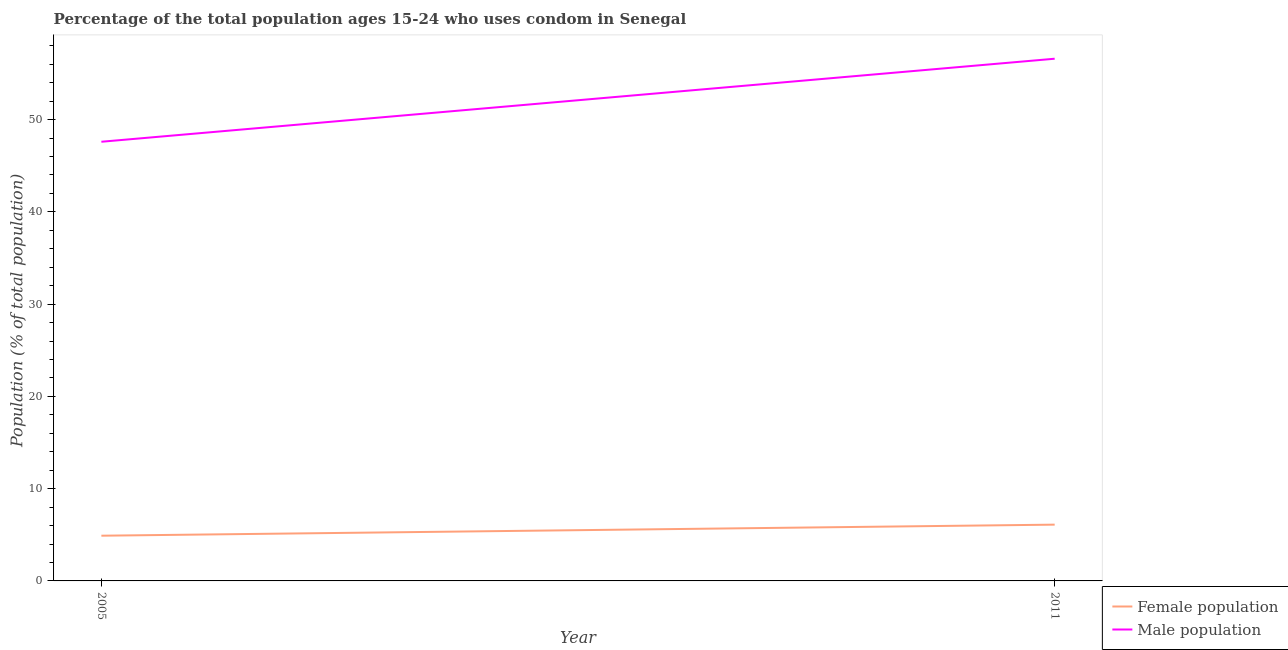Does the line corresponding to male population intersect with the line corresponding to female population?
Your response must be concise. No. Is the number of lines equal to the number of legend labels?
Provide a short and direct response. Yes. What is the female population in 2005?
Your answer should be compact. 4.9. Across all years, what is the maximum male population?
Your answer should be very brief. 56.6. Across all years, what is the minimum male population?
Provide a succinct answer. 47.6. In which year was the female population maximum?
Make the answer very short. 2011. In which year was the male population minimum?
Provide a succinct answer. 2005. What is the total male population in the graph?
Ensure brevity in your answer.  104.2. What is the difference between the female population in 2005 and that in 2011?
Offer a very short reply. -1.2. What is the difference between the male population in 2011 and the female population in 2005?
Ensure brevity in your answer.  51.7. In the year 2005, what is the difference between the male population and female population?
Your answer should be compact. 42.7. What is the ratio of the female population in 2005 to that in 2011?
Offer a terse response. 0.8. Does the male population monotonically increase over the years?
Offer a very short reply. Yes. Is the male population strictly greater than the female population over the years?
Your response must be concise. Yes. Is the female population strictly less than the male population over the years?
Your response must be concise. Yes. How many lines are there?
Offer a terse response. 2. How many years are there in the graph?
Give a very brief answer. 2. What is the title of the graph?
Ensure brevity in your answer.  Percentage of the total population ages 15-24 who uses condom in Senegal. What is the label or title of the X-axis?
Your answer should be compact. Year. What is the label or title of the Y-axis?
Your response must be concise. Population (% of total population) . What is the Population (% of total population)  in Female population in 2005?
Provide a succinct answer. 4.9. What is the Population (% of total population)  of Male population in 2005?
Offer a very short reply. 47.6. What is the Population (% of total population)  in Female population in 2011?
Provide a succinct answer. 6.1. What is the Population (% of total population)  in Male population in 2011?
Give a very brief answer. 56.6. Across all years, what is the maximum Population (% of total population)  in Male population?
Provide a succinct answer. 56.6. Across all years, what is the minimum Population (% of total population)  in Female population?
Your response must be concise. 4.9. Across all years, what is the minimum Population (% of total population)  of Male population?
Provide a short and direct response. 47.6. What is the total Population (% of total population)  in Male population in the graph?
Your answer should be compact. 104.2. What is the difference between the Population (% of total population)  of Female population in 2005 and that in 2011?
Provide a succinct answer. -1.2. What is the difference between the Population (% of total population)  of Male population in 2005 and that in 2011?
Give a very brief answer. -9. What is the difference between the Population (% of total population)  of Female population in 2005 and the Population (% of total population)  of Male population in 2011?
Provide a short and direct response. -51.7. What is the average Population (% of total population)  in Female population per year?
Keep it short and to the point. 5.5. What is the average Population (% of total population)  in Male population per year?
Your response must be concise. 52.1. In the year 2005, what is the difference between the Population (% of total population)  in Female population and Population (% of total population)  in Male population?
Keep it short and to the point. -42.7. In the year 2011, what is the difference between the Population (% of total population)  of Female population and Population (% of total population)  of Male population?
Keep it short and to the point. -50.5. What is the ratio of the Population (% of total population)  in Female population in 2005 to that in 2011?
Make the answer very short. 0.8. What is the ratio of the Population (% of total population)  in Male population in 2005 to that in 2011?
Your answer should be compact. 0.84. What is the difference between the highest and the second highest Population (% of total population)  in Female population?
Make the answer very short. 1.2. What is the difference between the highest and the second highest Population (% of total population)  of Male population?
Provide a succinct answer. 9. What is the difference between the highest and the lowest Population (% of total population)  in Female population?
Make the answer very short. 1.2. What is the difference between the highest and the lowest Population (% of total population)  of Male population?
Offer a very short reply. 9. 